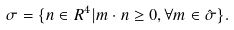<formula> <loc_0><loc_0><loc_500><loc_500>\sigma = \{ n \in { R } ^ { 4 } | m \cdot n \geq 0 , \forall m \in \hat { \sigma } \} .</formula> 